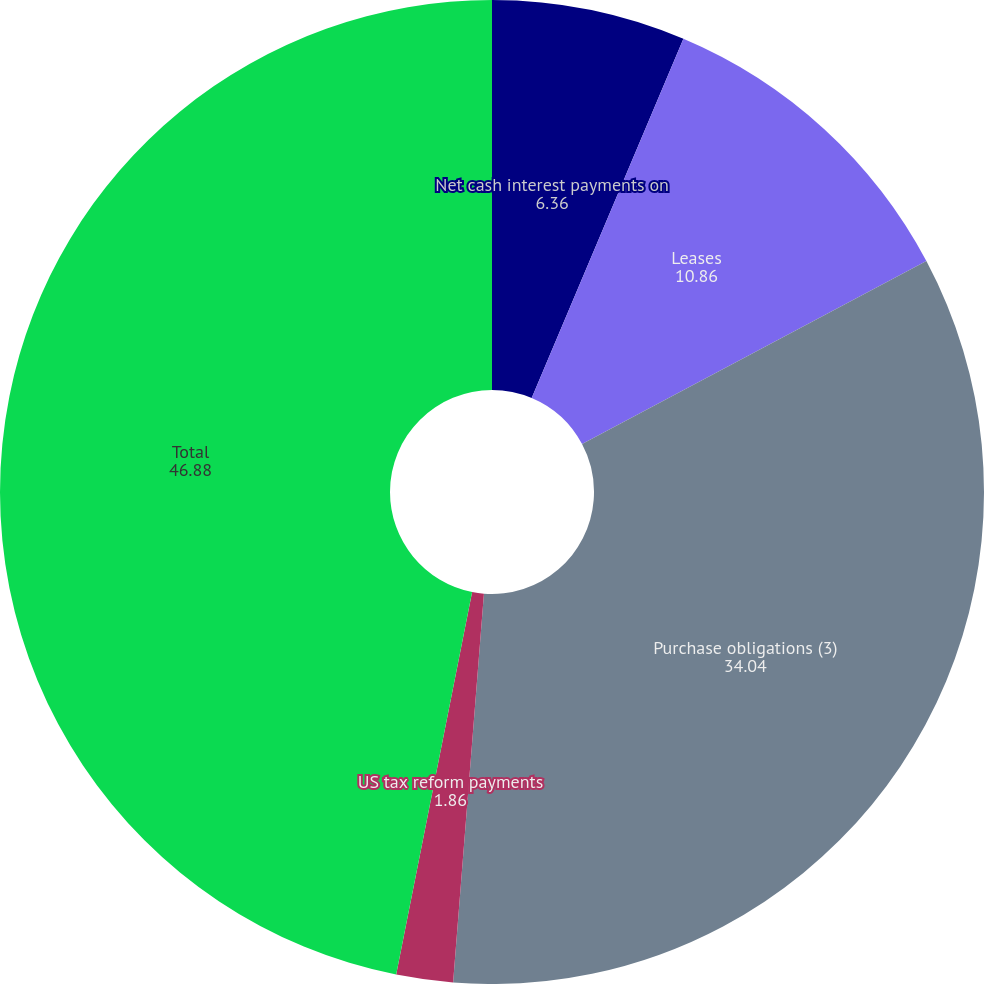Convert chart to OTSL. <chart><loc_0><loc_0><loc_500><loc_500><pie_chart><fcel>Net cash interest payments on<fcel>Leases<fcel>Purchase obligations (3)<fcel>US tax reform payments<fcel>Total<nl><fcel>6.36%<fcel>10.86%<fcel>34.04%<fcel>1.86%<fcel>46.88%<nl></chart> 